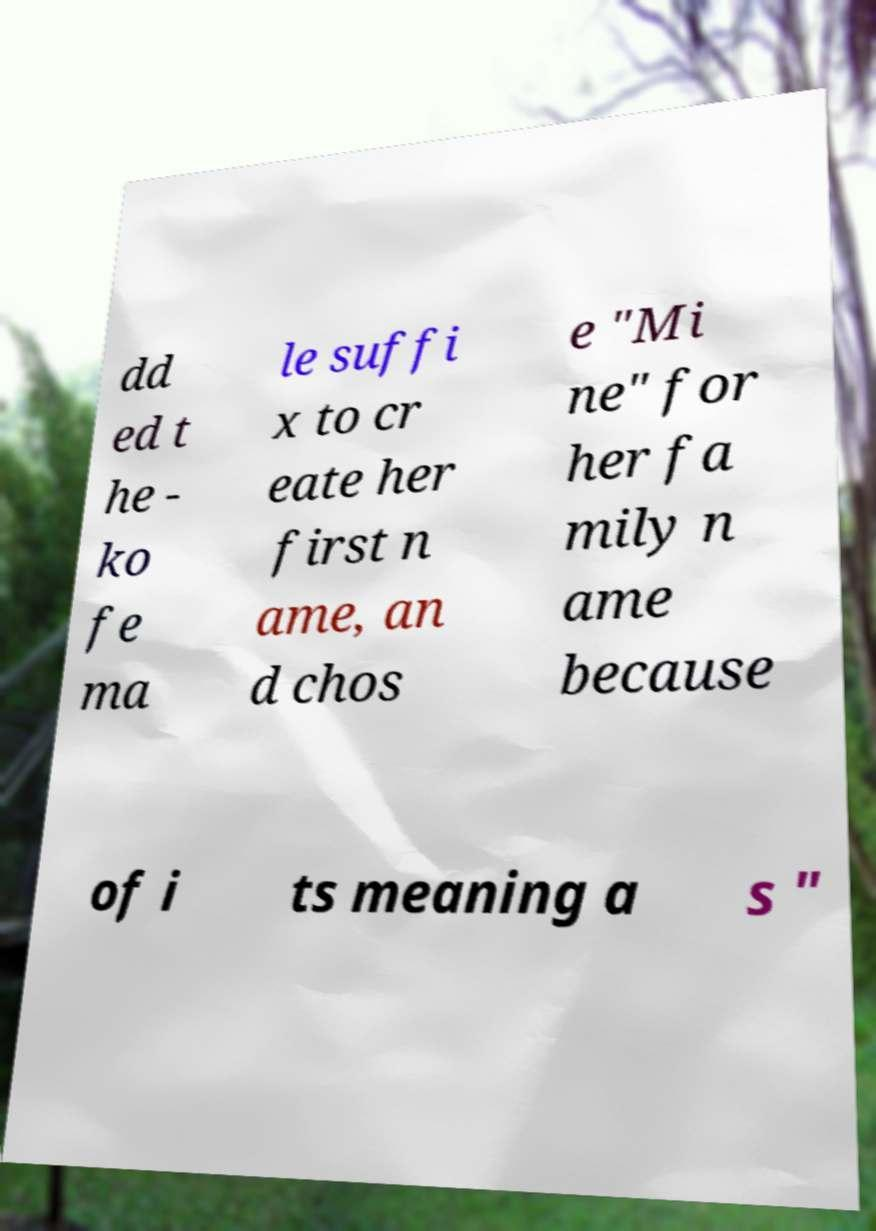Please read and relay the text visible in this image. What does it say? dd ed t he - ko fe ma le suffi x to cr eate her first n ame, an d chos e "Mi ne" for her fa mily n ame because of i ts meaning a s " 